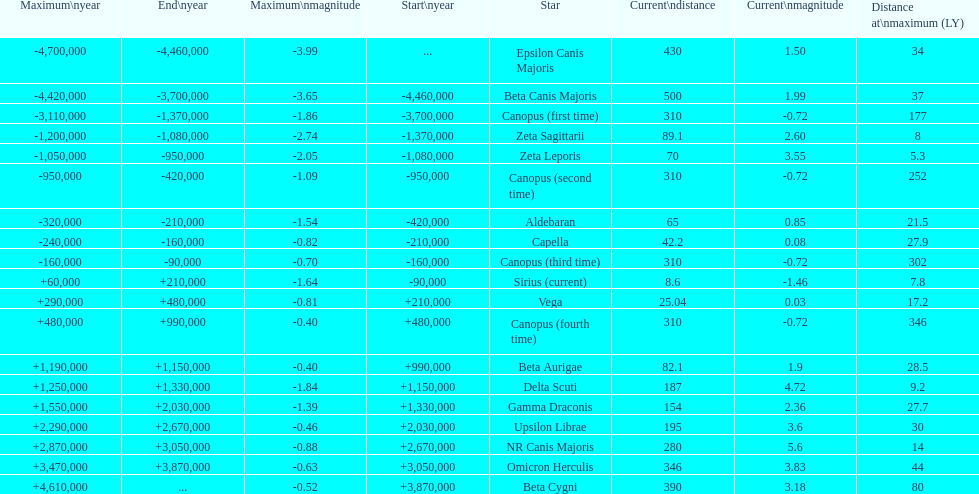What is the difference in the nearest current distance and farthest current distance? 491.4. 